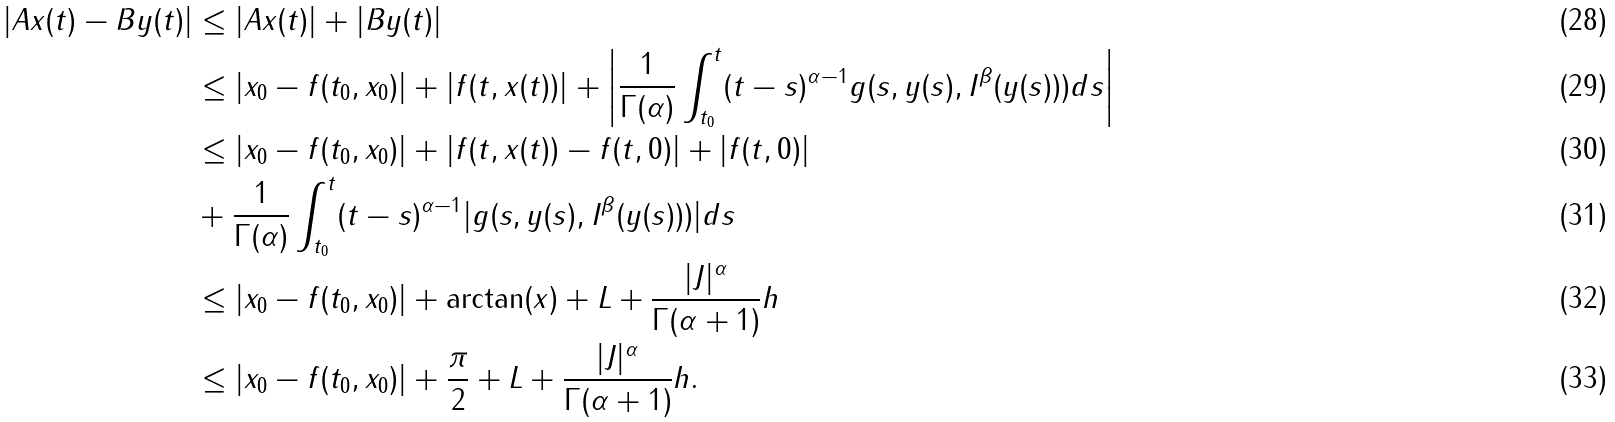Convert formula to latex. <formula><loc_0><loc_0><loc_500><loc_500>| A x ( t ) - B y ( t ) | & \leq | A x ( t ) | + | B y ( t ) | \\ & \leq | x _ { 0 } - f ( t _ { 0 } , x _ { 0 } ) | + | f ( t , x ( t ) ) | + \left | \frac { 1 } { \Gamma ( \alpha ) } \int _ { t _ { 0 } } ^ { t } ( t - s ) ^ { \alpha - 1 } g ( s , y ( s ) , I ^ { \beta } ( y ( s ) ) ) d s \right | \\ & \leq | x _ { 0 } - f ( t _ { 0 } , x _ { 0 } ) | + | f ( t , x ( t ) ) - f ( t , 0 ) | + | f ( t , 0 ) | \\ & + \frac { 1 } { \Gamma ( \alpha ) } \int _ { t _ { 0 } } ^ { t } ( t - s ) ^ { \alpha - 1 } | g ( s , y ( s ) , I ^ { \beta } ( y ( s ) ) ) | d s \\ & \leq | x _ { 0 } - f ( t _ { 0 } , x _ { 0 } ) | + \arctan ( \| x \| ) + L + \frac { | J | ^ { \alpha } } { \Gamma ( \alpha + 1 ) } \| h \| \\ & \leq | x _ { 0 } - f ( t _ { 0 } , x _ { 0 } ) | + \frac { \pi } { 2 } + L + \frac { | J | ^ { \alpha } } { \Gamma ( \alpha + 1 ) } \| h \| .</formula> 